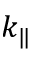Convert formula to latex. <formula><loc_0><loc_0><loc_500><loc_500>k _ { \| }</formula> 